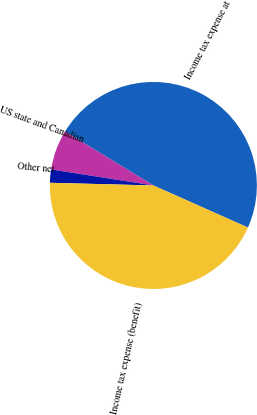<chart> <loc_0><loc_0><loc_500><loc_500><pie_chart><fcel>Income tax expense at<fcel>US state and Canadian<fcel>Other net<fcel>Income tax expense (benefit)<nl><fcel>47.94%<fcel>6.25%<fcel>2.06%<fcel>43.75%<nl></chart> 